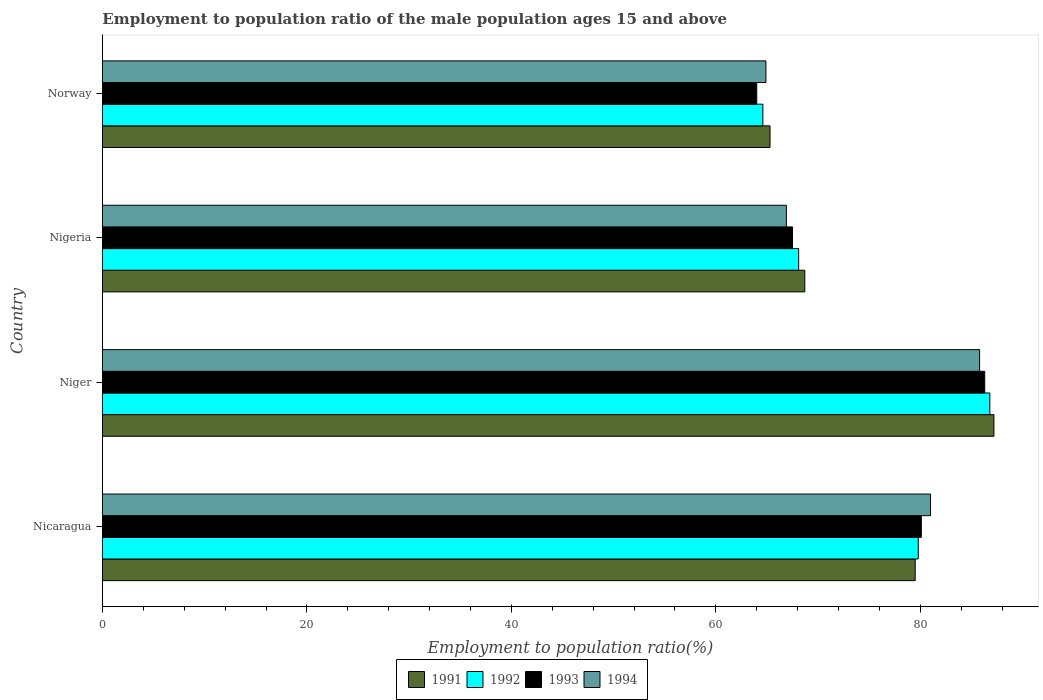Are the number of bars per tick equal to the number of legend labels?
Your answer should be compact. Yes. Are the number of bars on each tick of the Y-axis equal?
Make the answer very short. Yes. What is the label of the 4th group of bars from the top?
Give a very brief answer. Nicaragua. What is the employment to population ratio in 1994 in Niger?
Offer a very short reply. 85.8. Across all countries, what is the maximum employment to population ratio in 1991?
Your answer should be compact. 87.2. Across all countries, what is the minimum employment to population ratio in 1992?
Provide a short and direct response. 64.6. In which country was the employment to population ratio in 1994 maximum?
Make the answer very short. Niger. What is the total employment to population ratio in 1993 in the graph?
Ensure brevity in your answer.  297.9. What is the difference between the employment to population ratio in 1992 in Nigeria and that in Norway?
Your answer should be very brief. 3.5. What is the difference between the employment to population ratio in 1991 in Nigeria and the employment to population ratio in 1994 in Norway?
Offer a very short reply. 3.8. What is the average employment to population ratio in 1992 per country?
Offer a very short reply. 74.83. What is the difference between the employment to population ratio in 1991 and employment to population ratio in 1994 in Niger?
Provide a succinct answer. 1.4. In how many countries, is the employment to population ratio in 1991 greater than 52 %?
Ensure brevity in your answer.  4. What is the ratio of the employment to population ratio in 1991 in Nigeria to that in Norway?
Make the answer very short. 1.05. Is the difference between the employment to population ratio in 1991 in Niger and Norway greater than the difference between the employment to population ratio in 1994 in Niger and Norway?
Your answer should be very brief. Yes. What is the difference between the highest and the second highest employment to population ratio in 1991?
Provide a succinct answer. 7.7. What is the difference between the highest and the lowest employment to population ratio in 1994?
Offer a very short reply. 20.9. Is the sum of the employment to population ratio in 1993 in Nigeria and Norway greater than the maximum employment to population ratio in 1992 across all countries?
Offer a very short reply. Yes. Is it the case that in every country, the sum of the employment to population ratio in 1992 and employment to population ratio in 1994 is greater than the sum of employment to population ratio in 1991 and employment to population ratio in 1993?
Provide a short and direct response. No. What does the 3rd bar from the bottom in Nigeria represents?
Your response must be concise. 1993. Are all the bars in the graph horizontal?
Provide a succinct answer. Yes. Does the graph contain grids?
Provide a succinct answer. No. How many legend labels are there?
Your response must be concise. 4. How are the legend labels stacked?
Provide a succinct answer. Horizontal. What is the title of the graph?
Offer a very short reply. Employment to population ratio of the male population ages 15 and above. Does "1977" appear as one of the legend labels in the graph?
Your response must be concise. No. What is the label or title of the X-axis?
Provide a short and direct response. Employment to population ratio(%). What is the Employment to population ratio(%) in 1991 in Nicaragua?
Ensure brevity in your answer.  79.5. What is the Employment to population ratio(%) in 1992 in Nicaragua?
Keep it short and to the point. 79.8. What is the Employment to population ratio(%) in 1993 in Nicaragua?
Give a very brief answer. 80.1. What is the Employment to population ratio(%) of 1991 in Niger?
Offer a terse response. 87.2. What is the Employment to population ratio(%) of 1992 in Niger?
Provide a succinct answer. 86.8. What is the Employment to population ratio(%) of 1993 in Niger?
Provide a short and direct response. 86.3. What is the Employment to population ratio(%) of 1994 in Niger?
Offer a very short reply. 85.8. What is the Employment to population ratio(%) in 1991 in Nigeria?
Your response must be concise. 68.7. What is the Employment to population ratio(%) in 1992 in Nigeria?
Keep it short and to the point. 68.1. What is the Employment to population ratio(%) of 1993 in Nigeria?
Keep it short and to the point. 67.5. What is the Employment to population ratio(%) of 1994 in Nigeria?
Offer a terse response. 66.9. What is the Employment to population ratio(%) of 1991 in Norway?
Your answer should be compact. 65.3. What is the Employment to population ratio(%) in 1992 in Norway?
Give a very brief answer. 64.6. What is the Employment to population ratio(%) in 1994 in Norway?
Your answer should be compact. 64.9. Across all countries, what is the maximum Employment to population ratio(%) in 1991?
Your answer should be very brief. 87.2. Across all countries, what is the maximum Employment to population ratio(%) of 1992?
Provide a short and direct response. 86.8. Across all countries, what is the maximum Employment to population ratio(%) in 1993?
Keep it short and to the point. 86.3. Across all countries, what is the maximum Employment to population ratio(%) in 1994?
Offer a very short reply. 85.8. Across all countries, what is the minimum Employment to population ratio(%) of 1991?
Make the answer very short. 65.3. Across all countries, what is the minimum Employment to population ratio(%) of 1992?
Ensure brevity in your answer.  64.6. Across all countries, what is the minimum Employment to population ratio(%) in 1993?
Give a very brief answer. 64. Across all countries, what is the minimum Employment to population ratio(%) of 1994?
Your answer should be compact. 64.9. What is the total Employment to population ratio(%) in 1991 in the graph?
Provide a succinct answer. 300.7. What is the total Employment to population ratio(%) of 1992 in the graph?
Your response must be concise. 299.3. What is the total Employment to population ratio(%) in 1993 in the graph?
Give a very brief answer. 297.9. What is the total Employment to population ratio(%) in 1994 in the graph?
Provide a short and direct response. 298.6. What is the difference between the Employment to population ratio(%) of 1991 in Nicaragua and that in Niger?
Keep it short and to the point. -7.7. What is the difference between the Employment to population ratio(%) of 1993 in Nicaragua and that in Niger?
Your answer should be very brief. -6.2. What is the difference between the Employment to population ratio(%) of 1994 in Nicaragua and that in Niger?
Offer a very short reply. -4.8. What is the difference between the Employment to population ratio(%) in 1991 in Nicaragua and that in Nigeria?
Your answer should be compact. 10.8. What is the difference between the Employment to population ratio(%) in 1994 in Nicaragua and that in Nigeria?
Provide a succinct answer. 14.1. What is the difference between the Employment to population ratio(%) of 1994 in Nicaragua and that in Norway?
Your response must be concise. 16.1. What is the difference between the Employment to population ratio(%) of 1991 in Niger and that in Nigeria?
Offer a terse response. 18.5. What is the difference between the Employment to population ratio(%) in 1993 in Niger and that in Nigeria?
Ensure brevity in your answer.  18.8. What is the difference between the Employment to population ratio(%) in 1994 in Niger and that in Nigeria?
Provide a succinct answer. 18.9. What is the difference between the Employment to population ratio(%) of 1991 in Niger and that in Norway?
Give a very brief answer. 21.9. What is the difference between the Employment to population ratio(%) in 1992 in Niger and that in Norway?
Ensure brevity in your answer.  22.2. What is the difference between the Employment to population ratio(%) of 1993 in Niger and that in Norway?
Offer a very short reply. 22.3. What is the difference between the Employment to population ratio(%) in 1994 in Niger and that in Norway?
Keep it short and to the point. 20.9. What is the difference between the Employment to population ratio(%) in 1991 in Nigeria and that in Norway?
Ensure brevity in your answer.  3.4. What is the difference between the Employment to population ratio(%) in 1994 in Nigeria and that in Norway?
Offer a very short reply. 2. What is the difference between the Employment to population ratio(%) of 1991 in Nicaragua and the Employment to population ratio(%) of 1992 in Niger?
Ensure brevity in your answer.  -7.3. What is the difference between the Employment to population ratio(%) of 1991 in Nicaragua and the Employment to population ratio(%) of 1993 in Niger?
Make the answer very short. -6.8. What is the difference between the Employment to population ratio(%) in 1991 in Nicaragua and the Employment to population ratio(%) in 1994 in Niger?
Your answer should be very brief. -6.3. What is the difference between the Employment to population ratio(%) in 1992 in Nicaragua and the Employment to population ratio(%) in 1993 in Niger?
Offer a terse response. -6.5. What is the difference between the Employment to population ratio(%) in 1993 in Nicaragua and the Employment to population ratio(%) in 1994 in Niger?
Give a very brief answer. -5.7. What is the difference between the Employment to population ratio(%) of 1991 in Nicaragua and the Employment to population ratio(%) of 1992 in Nigeria?
Provide a short and direct response. 11.4. What is the difference between the Employment to population ratio(%) in 1991 in Nicaragua and the Employment to population ratio(%) in 1993 in Nigeria?
Make the answer very short. 12. What is the difference between the Employment to population ratio(%) of 1993 in Nicaragua and the Employment to population ratio(%) of 1994 in Nigeria?
Make the answer very short. 13.2. What is the difference between the Employment to population ratio(%) of 1991 in Nicaragua and the Employment to population ratio(%) of 1992 in Norway?
Make the answer very short. 14.9. What is the difference between the Employment to population ratio(%) of 1991 in Nicaragua and the Employment to population ratio(%) of 1994 in Norway?
Your answer should be very brief. 14.6. What is the difference between the Employment to population ratio(%) of 1993 in Nicaragua and the Employment to population ratio(%) of 1994 in Norway?
Give a very brief answer. 15.2. What is the difference between the Employment to population ratio(%) of 1991 in Niger and the Employment to population ratio(%) of 1992 in Nigeria?
Ensure brevity in your answer.  19.1. What is the difference between the Employment to population ratio(%) in 1991 in Niger and the Employment to population ratio(%) in 1993 in Nigeria?
Keep it short and to the point. 19.7. What is the difference between the Employment to population ratio(%) in 1991 in Niger and the Employment to population ratio(%) in 1994 in Nigeria?
Ensure brevity in your answer.  20.3. What is the difference between the Employment to population ratio(%) of 1992 in Niger and the Employment to population ratio(%) of 1993 in Nigeria?
Offer a terse response. 19.3. What is the difference between the Employment to population ratio(%) of 1991 in Niger and the Employment to population ratio(%) of 1992 in Norway?
Make the answer very short. 22.6. What is the difference between the Employment to population ratio(%) in 1991 in Niger and the Employment to population ratio(%) in 1993 in Norway?
Ensure brevity in your answer.  23.2. What is the difference between the Employment to population ratio(%) in 1991 in Niger and the Employment to population ratio(%) in 1994 in Norway?
Your answer should be very brief. 22.3. What is the difference between the Employment to population ratio(%) of 1992 in Niger and the Employment to population ratio(%) of 1993 in Norway?
Ensure brevity in your answer.  22.8. What is the difference between the Employment to population ratio(%) in 1992 in Niger and the Employment to population ratio(%) in 1994 in Norway?
Offer a very short reply. 21.9. What is the difference between the Employment to population ratio(%) of 1993 in Niger and the Employment to population ratio(%) of 1994 in Norway?
Provide a short and direct response. 21.4. What is the average Employment to population ratio(%) in 1991 per country?
Give a very brief answer. 75.17. What is the average Employment to population ratio(%) in 1992 per country?
Offer a very short reply. 74.83. What is the average Employment to population ratio(%) in 1993 per country?
Your answer should be compact. 74.47. What is the average Employment to population ratio(%) in 1994 per country?
Ensure brevity in your answer.  74.65. What is the difference between the Employment to population ratio(%) of 1991 and Employment to population ratio(%) of 1994 in Nicaragua?
Make the answer very short. -1.5. What is the difference between the Employment to population ratio(%) in 1992 and Employment to population ratio(%) in 1993 in Nicaragua?
Your answer should be very brief. -0.3. What is the difference between the Employment to population ratio(%) of 1992 and Employment to population ratio(%) of 1994 in Niger?
Offer a very short reply. 1. What is the difference between the Employment to population ratio(%) in 1993 and Employment to population ratio(%) in 1994 in Niger?
Your answer should be compact. 0.5. What is the difference between the Employment to population ratio(%) of 1991 and Employment to population ratio(%) of 1993 in Nigeria?
Offer a very short reply. 1.2. What is the difference between the Employment to population ratio(%) of 1992 and Employment to population ratio(%) of 1993 in Nigeria?
Provide a succinct answer. 0.6. What is the difference between the Employment to population ratio(%) of 1991 and Employment to population ratio(%) of 1992 in Norway?
Offer a very short reply. 0.7. What is the difference between the Employment to population ratio(%) in 1991 and Employment to population ratio(%) in 1994 in Norway?
Give a very brief answer. 0.4. What is the difference between the Employment to population ratio(%) of 1992 and Employment to population ratio(%) of 1993 in Norway?
Keep it short and to the point. 0.6. What is the difference between the Employment to population ratio(%) of 1993 and Employment to population ratio(%) of 1994 in Norway?
Offer a very short reply. -0.9. What is the ratio of the Employment to population ratio(%) in 1991 in Nicaragua to that in Niger?
Ensure brevity in your answer.  0.91. What is the ratio of the Employment to population ratio(%) of 1992 in Nicaragua to that in Niger?
Your response must be concise. 0.92. What is the ratio of the Employment to population ratio(%) in 1993 in Nicaragua to that in Niger?
Keep it short and to the point. 0.93. What is the ratio of the Employment to population ratio(%) in 1994 in Nicaragua to that in Niger?
Your response must be concise. 0.94. What is the ratio of the Employment to population ratio(%) in 1991 in Nicaragua to that in Nigeria?
Provide a short and direct response. 1.16. What is the ratio of the Employment to population ratio(%) of 1992 in Nicaragua to that in Nigeria?
Provide a succinct answer. 1.17. What is the ratio of the Employment to population ratio(%) of 1993 in Nicaragua to that in Nigeria?
Your answer should be very brief. 1.19. What is the ratio of the Employment to population ratio(%) of 1994 in Nicaragua to that in Nigeria?
Make the answer very short. 1.21. What is the ratio of the Employment to population ratio(%) in 1991 in Nicaragua to that in Norway?
Provide a succinct answer. 1.22. What is the ratio of the Employment to population ratio(%) in 1992 in Nicaragua to that in Norway?
Your answer should be very brief. 1.24. What is the ratio of the Employment to population ratio(%) of 1993 in Nicaragua to that in Norway?
Your answer should be very brief. 1.25. What is the ratio of the Employment to population ratio(%) in 1994 in Nicaragua to that in Norway?
Ensure brevity in your answer.  1.25. What is the ratio of the Employment to population ratio(%) of 1991 in Niger to that in Nigeria?
Ensure brevity in your answer.  1.27. What is the ratio of the Employment to population ratio(%) in 1992 in Niger to that in Nigeria?
Your response must be concise. 1.27. What is the ratio of the Employment to population ratio(%) in 1993 in Niger to that in Nigeria?
Your answer should be compact. 1.28. What is the ratio of the Employment to population ratio(%) of 1994 in Niger to that in Nigeria?
Your answer should be very brief. 1.28. What is the ratio of the Employment to population ratio(%) of 1991 in Niger to that in Norway?
Make the answer very short. 1.34. What is the ratio of the Employment to population ratio(%) in 1992 in Niger to that in Norway?
Offer a very short reply. 1.34. What is the ratio of the Employment to population ratio(%) of 1993 in Niger to that in Norway?
Your answer should be very brief. 1.35. What is the ratio of the Employment to population ratio(%) of 1994 in Niger to that in Norway?
Give a very brief answer. 1.32. What is the ratio of the Employment to population ratio(%) of 1991 in Nigeria to that in Norway?
Provide a short and direct response. 1.05. What is the ratio of the Employment to population ratio(%) in 1992 in Nigeria to that in Norway?
Your response must be concise. 1.05. What is the ratio of the Employment to population ratio(%) in 1993 in Nigeria to that in Norway?
Ensure brevity in your answer.  1.05. What is the ratio of the Employment to population ratio(%) in 1994 in Nigeria to that in Norway?
Offer a very short reply. 1.03. What is the difference between the highest and the second highest Employment to population ratio(%) in 1991?
Give a very brief answer. 7.7. What is the difference between the highest and the second highest Employment to population ratio(%) in 1993?
Ensure brevity in your answer.  6.2. What is the difference between the highest and the second highest Employment to population ratio(%) in 1994?
Keep it short and to the point. 4.8. What is the difference between the highest and the lowest Employment to population ratio(%) in 1991?
Ensure brevity in your answer.  21.9. What is the difference between the highest and the lowest Employment to population ratio(%) of 1992?
Give a very brief answer. 22.2. What is the difference between the highest and the lowest Employment to population ratio(%) in 1993?
Your answer should be very brief. 22.3. What is the difference between the highest and the lowest Employment to population ratio(%) in 1994?
Provide a succinct answer. 20.9. 